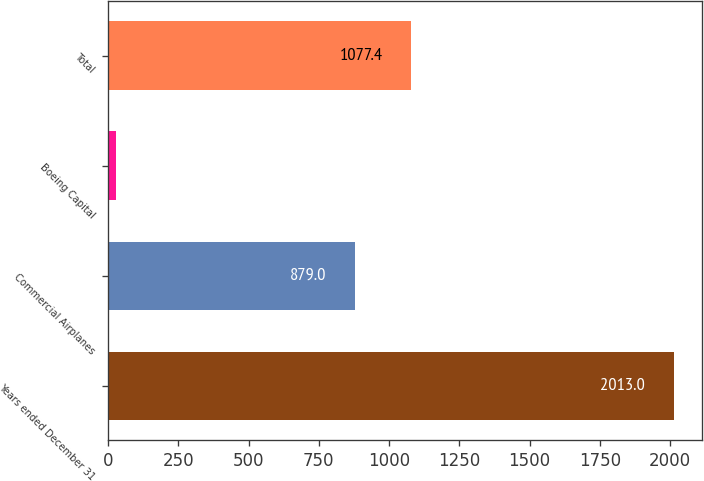Convert chart. <chart><loc_0><loc_0><loc_500><loc_500><bar_chart><fcel>Years ended December 31<fcel>Commercial Airplanes<fcel>Boeing Capital<fcel>Total<nl><fcel>2013<fcel>879<fcel>29<fcel>1077.4<nl></chart> 